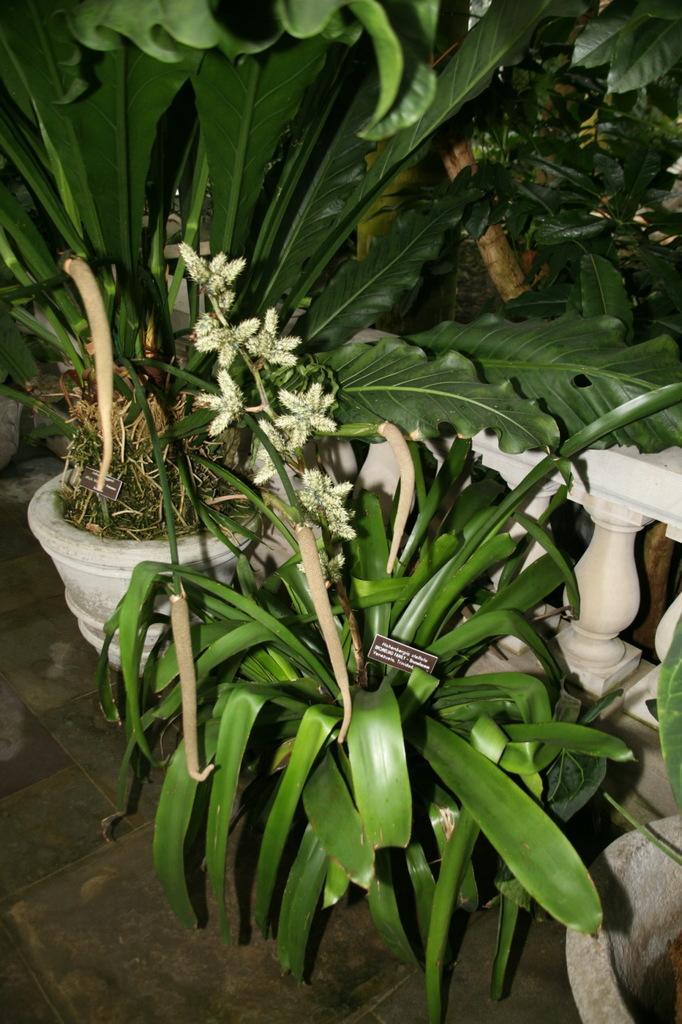Describe this image in one or two sentences. In this image I can see plant pots and a white color fence. 